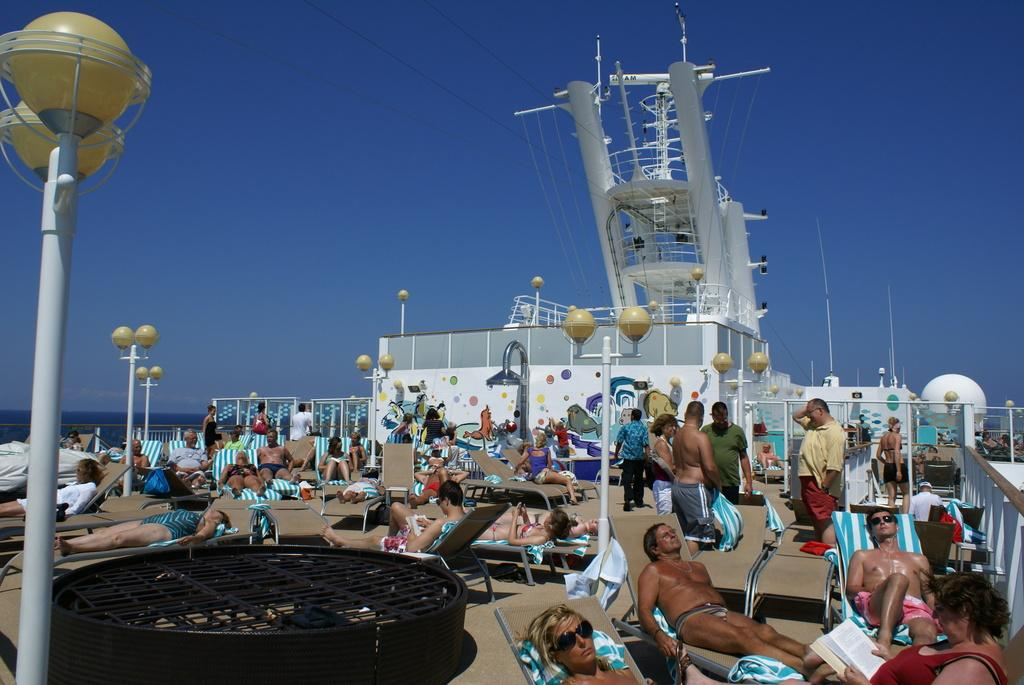Who or what can be seen in the image? There are people in the image. What are the people doing in the image? The people are sitting on chairs. What structures are present in the image? There are poles with lights in the image. What can be seen in the distance in the image? There is a sea visible in the background of the image. What type of goat can be seen climbing the poles with lights in the image? There are no goats present in the image; it features people sitting on chairs and poles with lights. 